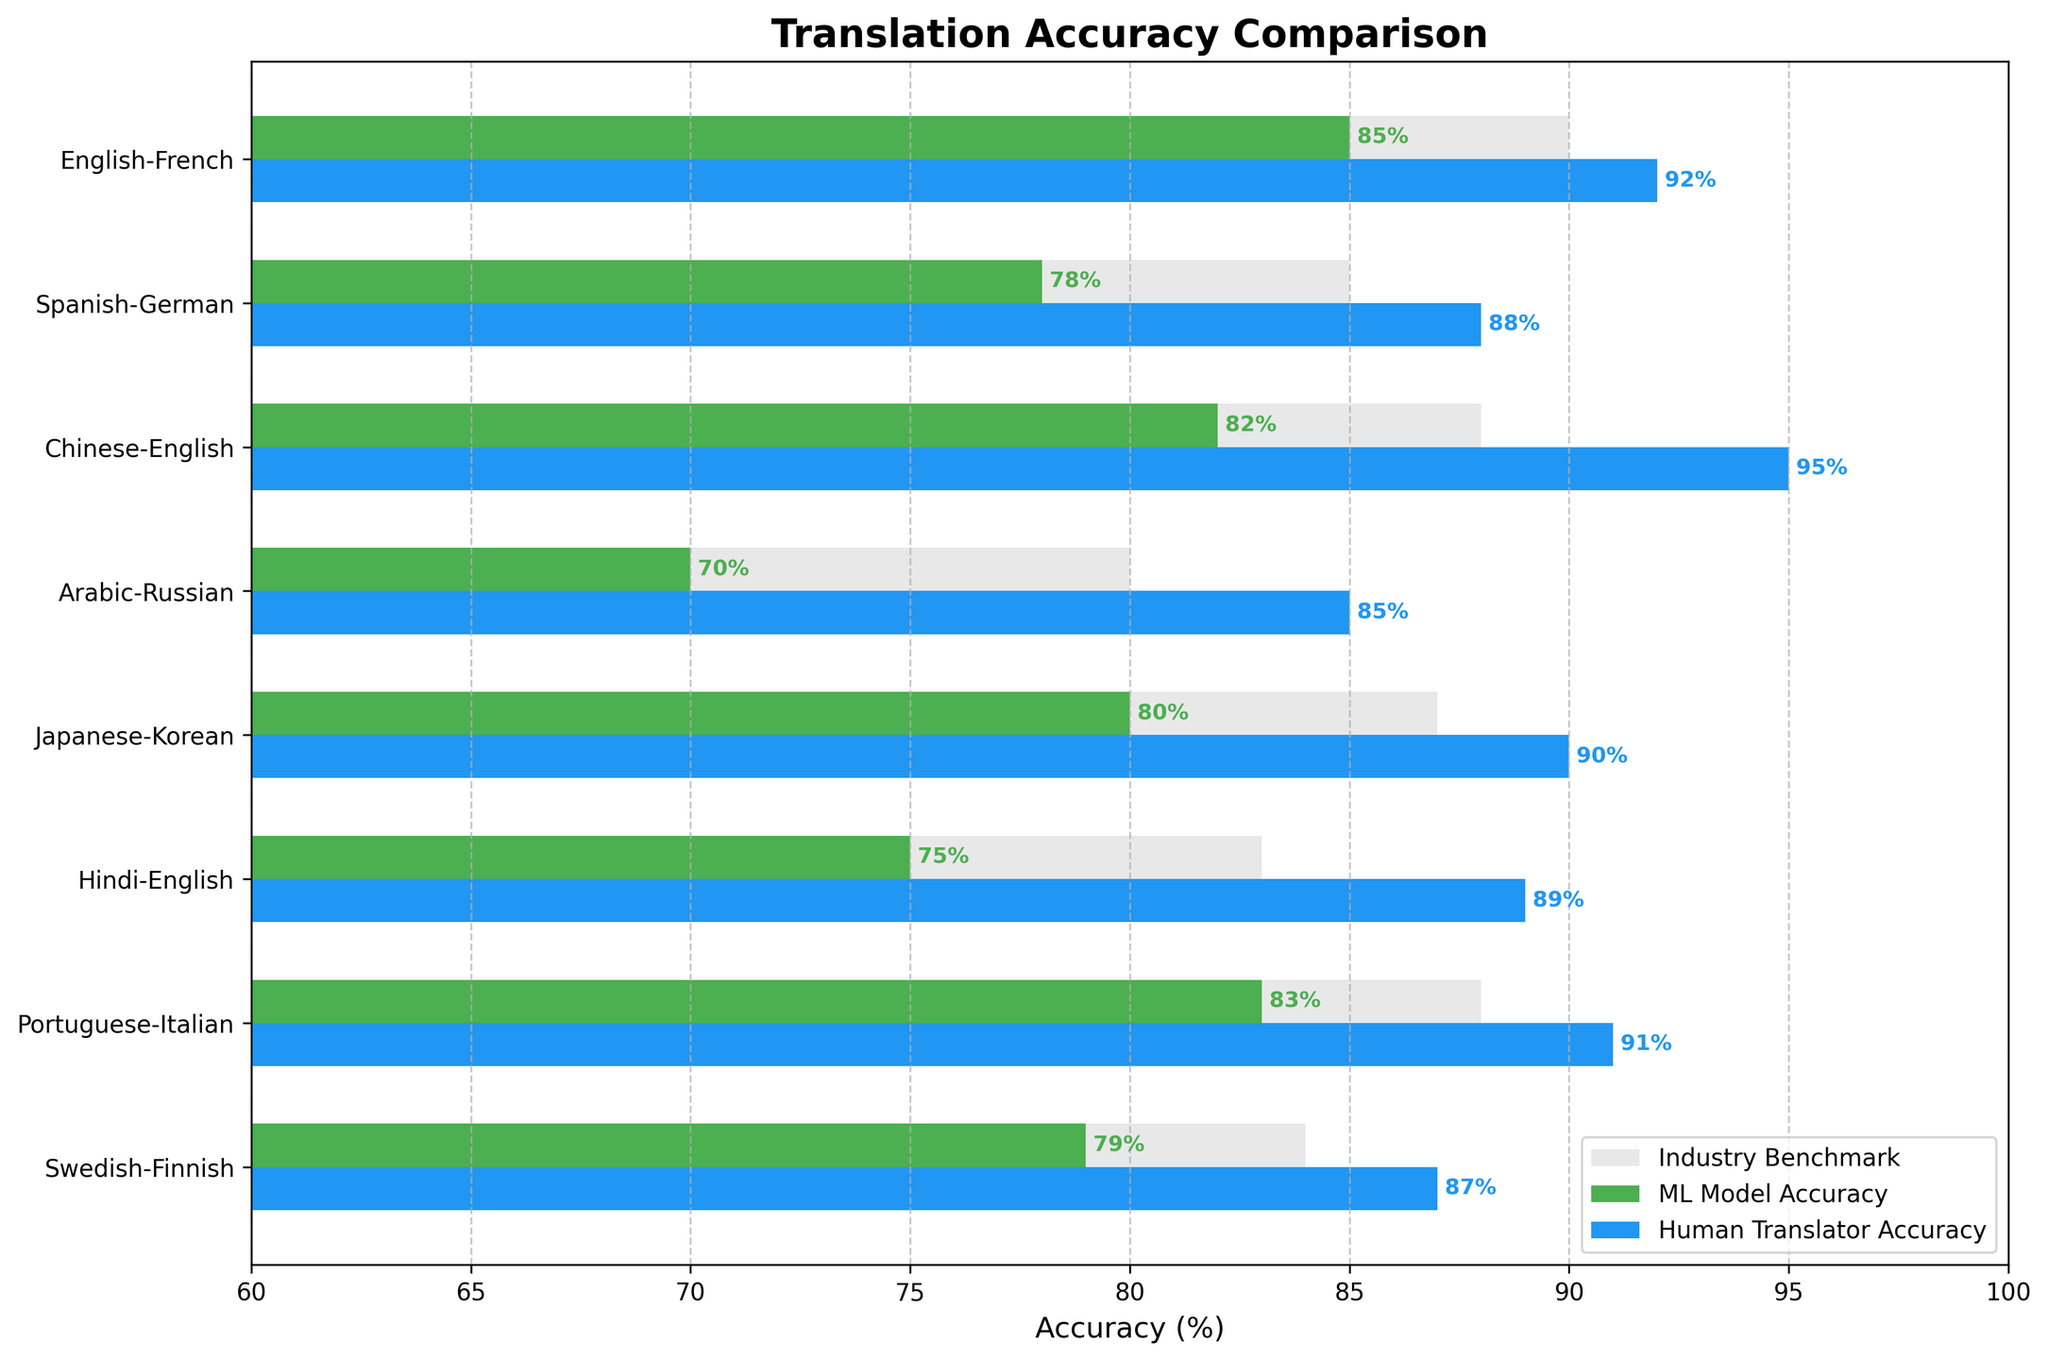what is the highest human translator accuracy among all language pairs? Find the highest value in the human translator accuracy bars.
Answer: 95 What is the difference between human translator and ML model accuracy for Arabic-Russian? For the Arabic-Russian pair, subtract ML model's accuracy (70) from that of the human translator (85).
Answer: 15 Which language pair has the lowest ML Model Accuracy? Look at the accuracy percentages for all language pairs and identify the lowest one.
Answer: Arabic-Russian Does the ML Model Accuracy for Japanese-Korean outperform the industry benchmark for the same pair? Compare the ML Model Accuracy (80) and the Industry Benchmark (87) for Japanese-Korean.
Answer: No How many language pairs have ML model accuracy higher than 80? Count the number of language pairs where the ML model accuracy exceeds 80.
Answer: 3 For which language pair is the difference between the industry benchmark and human translator accuracy the smallest? Subtract the industry benchmark from human translator accuracy for each language pair and find the smallest difference.
Answer: Hindi-English What is the average human translator accuracy across all language pairs? Sum the human translator accuracy percentages and divide by the number of language pairs. (92 + 88 + 95 + 85 + 90 + 89 + 91 + 87)/8 = 89.125
Answer: 89.125 